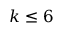<formula> <loc_0><loc_0><loc_500><loc_500>k \leq 6</formula> 